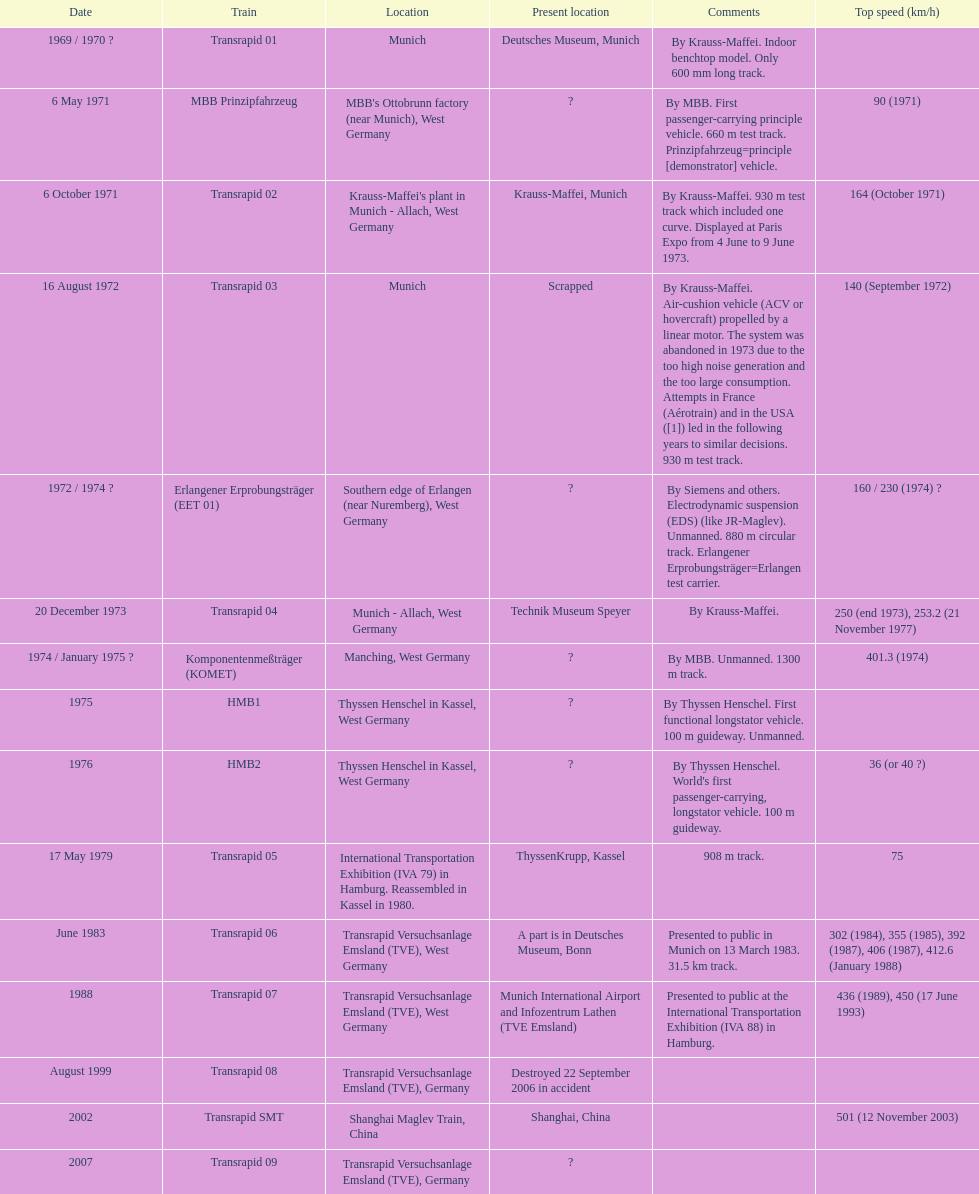Let me know the count of versions that are abandoned. 1. Can you give me this table as a dict? {'header': ['Date', 'Train', 'Location', 'Present location', 'Comments', 'Top speed (km/h)'], 'rows': [['1969 / 1970\xa0?', 'Transrapid 01', 'Munich', 'Deutsches Museum, Munich', 'By Krauss-Maffei. Indoor benchtop model. Only 600\xa0mm long track.', ''], ['6 May 1971', 'MBB Prinzipfahrzeug', "MBB's Ottobrunn factory (near Munich), West Germany", '?', 'By MBB. First passenger-carrying principle vehicle. 660 m test track. Prinzipfahrzeug=principle [demonstrator] vehicle.', '90 (1971)'], ['6 October 1971', 'Transrapid 02', "Krauss-Maffei's plant in Munich - Allach, West Germany", 'Krauss-Maffei, Munich', 'By Krauss-Maffei. 930 m test track which included one curve. Displayed at Paris Expo from 4 June to 9 June 1973.', '164 (October 1971)'], ['16 August 1972', 'Transrapid 03', 'Munich', 'Scrapped', 'By Krauss-Maffei. Air-cushion vehicle (ACV or hovercraft) propelled by a linear motor. The system was abandoned in 1973 due to the too high noise generation and the too large consumption. Attempts in France (Aérotrain) and in the USA ([1]) led in the following years to similar decisions. 930 m test track.', '140 (September 1972)'], ['1972 / 1974\xa0?', 'Erlangener Erprobungsträger (EET 01)', 'Southern edge of Erlangen (near Nuremberg), West Germany', '?', 'By Siemens and others. Electrodynamic suspension (EDS) (like JR-Maglev). Unmanned. 880 m circular track. Erlangener Erprobungsträger=Erlangen test carrier.', '160 / 230 (1974)\xa0?'], ['20 December 1973', 'Transrapid 04', 'Munich - Allach, West Germany', 'Technik Museum Speyer', 'By Krauss-Maffei.', '250 (end 1973), 253.2 (21 November 1977)'], ['1974 / January 1975\xa0?', 'Komponentenmeßträger (KOMET)', 'Manching, West Germany', '?', 'By MBB. Unmanned. 1300 m track.', '401.3 (1974)'], ['1975', 'HMB1', 'Thyssen Henschel in Kassel, West Germany', '?', 'By Thyssen Henschel. First functional longstator vehicle. 100 m guideway. Unmanned.', ''], ['1976', 'HMB2', 'Thyssen Henschel in Kassel, West Germany', '?', "By Thyssen Henschel. World's first passenger-carrying, longstator vehicle. 100 m guideway.", '36 (or 40\xa0?)'], ['17 May 1979', 'Transrapid 05', 'International Transportation Exhibition (IVA 79) in Hamburg. Reassembled in Kassel in 1980.', 'ThyssenKrupp, Kassel', '908 m track.', '75'], ['June 1983', 'Transrapid 06', 'Transrapid Versuchsanlage Emsland (TVE), West Germany', 'A part is in Deutsches Museum, Bonn', 'Presented to public in Munich on 13 March 1983. 31.5\xa0km track.', '302 (1984), 355 (1985), 392 (1987), 406 (1987), 412.6 (January 1988)'], ['1988', 'Transrapid 07', 'Transrapid Versuchsanlage Emsland (TVE), West Germany', 'Munich International Airport and Infozentrum Lathen (TVE Emsland)', 'Presented to public at the International Transportation Exhibition (IVA 88) in Hamburg.', '436 (1989), 450 (17 June 1993)'], ['August 1999', 'Transrapid 08', 'Transrapid Versuchsanlage Emsland (TVE), Germany', 'Destroyed 22 September 2006 in accident', '', ''], ['2002', 'Transrapid SMT', 'Shanghai Maglev Train, China', 'Shanghai, China', '', '501 (12 November 2003)'], ['2007', 'Transrapid 09', 'Transrapid Versuchsanlage Emsland (TVE), Germany', '?', '', '']]} 